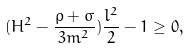<formula> <loc_0><loc_0><loc_500><loc_500>( H ^ { 2 } - \frac { \rho + \sigma } { 3 m ^ { 2 } } ) \frac { l ^ { 2 } } { 2 } - 1 \geq 0 ,</formula> 